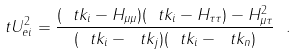<formula> <loc_0><loc_0><loc_500><loc_500>\ t U ^ { 2 } _ { e i } = \frac { ( \ t k _ { i } - H _ { \mu \mu } ) ( \ t k _ { i } - H _ { \tau \tau } ) - H ^ { 2 } _ { \mu \tau } } { ( \ t k _ { i } - \ t k _ { j } ) ( \ t k _ { i } - \ t k _ { n } ) } \ .</formula> 